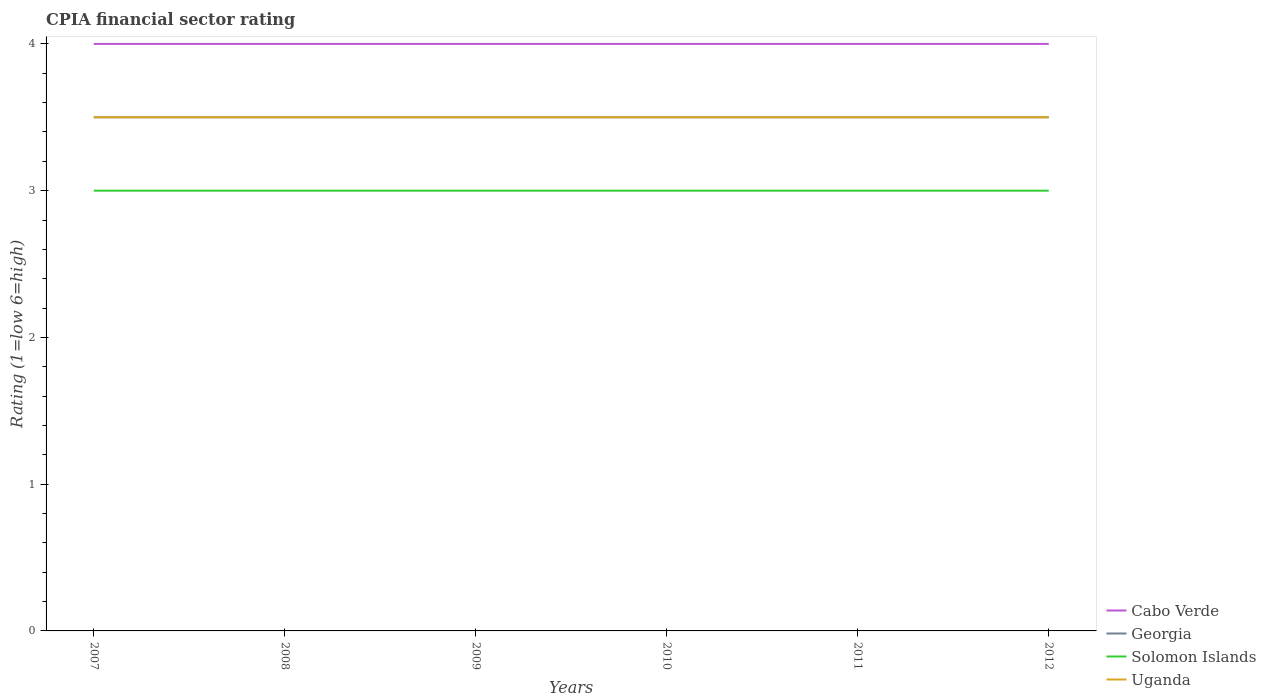How many different coloured lines are there?
Provide a succinct answer. 4. Does the line corresponding to Solomon Islands intersect with the line corresponding to Georgia?
Make the answer very short. No. What is the total CPIA rating in Solomon Islands in the graph?
Your answer should be compact. 0. Are the values on the major ticks of Y-axis written in scientific E-notation?
Your answer should be compact. No. How are the legend labels stacked?
Your response must be concise. Vertical. What is the title of the graph?
Make the answer very short. CPIA financial sector rating. Does "Guyana" appear as one of the legend labels in the graph?
Your answer should be compact. No. What is the label or title of the Y-axis?
Provide a succinct answer. Rating (1=low 6=high). What is the Rating (1=low 6=high) of Georgia in 2007?
Your response must be concise. 3.5. What is the Rating (1=low 6=high) in Solomon Islands in 2007?
Offer a very short reply. 3. What is the Rating (1=low 6=high) of Uganda in 2007?
Provide a succinct answer. 3.5. What is the Rating (1=low 6=high) in Cabo Verde in 2008?
Provide a succinct answer. 4. What is the Rating (1=low 6=high) of Georgia in 2008?
Your answer should be compact. 3.5. What is the Rating (1=low 6=high) in Uganda in 2008?
Offer a terse response. 3.5. What is the Rating (1=low 6=high) in Cabo Verde in 2009?
Offer a very short reply. 4. What is the Rating (1=low 6=high) of Georgia in 2009?
Offer a terse response. 3.5. What is the Rating (1=low 6=high) of Solomon Islands in 2009?
Offer a terse response. 3. What is the Rating (1=low 6=high) in Cabo Verde in 2010?
Give a very brief answer. 4. What is the Rating (1=low 6=high) in Georgia in 2010?
Your answer should be very brief. 3.5. What is the Rating (1=low 6=high) of Uganda in 2010?
Offer a terse response. 3.5. What is the Rating (1=low 6=high) of Solomon Islands in 2011?
Give a very brief answer. 3. What is the Rating (1=low 6=high) in Uganda in 2011?
Your response must be concise. 3.5. What is the Rating (1=low 6=high) in Cabo Verde in 2012?
Your answer should be compact. 4. What is the Rating (1=low 6=high) in Uganda in 2012?
Your response must be concise. 3.5. Across all years, what is the maximum Rating (1=low 6=high) of Georgia?
Make the answer very short. 3.5. Across all years, what is the maximum Rating (1=low 6=high) in Uganda?
Give a very brief answer. 3.5. Across all years, what is the minimum Rating (1=low 6=high) of Uganda?
Provide a short and direct response. 3.5. What is the total Rating (1=low 6=high) of Cabo Verde in the graph?
Offer a terse response. 24. What is the total Rating (1=low 6=high) in Georgia in the graph?
Your response must be concise. 21. What is the difference between the Rating (1=low 6=high) in Solomon Islands in 2007 and that in 2008?
Offer a very short reply. 0. What is the difference between the Rating (1=low 6=high) of Uganda in 2007 and that in 2008?
Ensure brevity in your answer.  0. What is the difference between the Rating (1=low 6=high) in Solomon Islands in 2007 and that in 2009?
Provide a succinct answer. 0. What is the difference between the Rating (1=low 6=high) in Uganda in 2007 and that in 2010?
Keep it short and to the point. 0. What is the difference between the Rating (1=low 6=high) in Georgia in 2007 and that in 2011?
Your answer should be compact. 0. What is the difference between the Rating (1=low 6=high) in Cabo Verde in 2007 and that in 2012?
Your answer should be very brief. 0. What is the difference between the Rating (1=low 6=high) in Georgia in 2007 and that in 2012?
Give a very brief answer. 0. What is the difference between the Rating (1=low 6=high) in Solomon Islands in 2007 and that in 2012?
Provide a succinct answer. 0. What is the difference between the Rating (1=low 6=high) of Uganda in 2008 and that in 2009?
Ensure brevity in your answer.  0. What is the difference between the Rating (1=low 6=high) of Cabo Verde in 2008 and that in 2010?
Give a very brief answer. 0. What is the difference between the Rating (1=low 6=high) of Georgia in 2008 and that in 2010?
Your answer should be very brief. 0. What is the difference between the Rating (1=low 6=high) in Solomon Islands in 2008 and that in 2010?
Provide a short and direct response. 0. What is the difference between the Rating (1=low 6=high) in Uganda in 2008 and that in 2010?
Give a very brief answer. 0. What is the difference between the Rating (1=low 6=high) in Cabo Verde in 2008 and that in 2011?
Offer a very short reply. 0. What is the difference between the Rating (1=low 6=high) in Georgia in 2008 and that in 2011?
Your answer should be very brief. 0. What is the difference between the Rating (1=low 6=high) of Solomon Islands in 2008 and that in 2011?
Your answer should be very brief. 0. What is the difference between the Rating (1=low 6=high) in Georgia in 2008 and that in 2012?
Give a very brief answer. 0. What is the difference between the Rating (1=low 6=high) in Solomon Islands in 2008 and that in 2012?
Provide a succinct answer. 0. What is the difference between the Rating (1=low 6=high) in Uganda in 2008 and that in 2012?
Your response must be concise. 0. What is the difference between the Rating (1=low 6=high) in Cabo Verde in 2009 and that in 2010?
Provide a succinct answer. 0. What is the difference between the Rating (1=low 6=high) in Solomon Islands in 2009 and that in 2010?
Your answer should be compact. 0. What is the difference between the Rating (1=low 6=high) in Uganda in 2009 and that in 2010?
Make the answer very short. 0. What is the difference between the Rating (1=low 6=high) of Cabo Verde in 2009 and that in 2011?
Your answer should be very brief. 0. What is the difference between the Rating (1=low 6=high) in Georgia in 2009 and that in 2011?
Your answer should be compact. 0. What is the difference between the Rating (1=low 6=high) of Cabo Verde in 2009 and that in 2012?
Provide a short and direct response. 0. What is the difference between the Rating (1=low 6=high) of Solomon Islands in 2009 and that in 2012?
Offer a very short reply. 0. What is the difference between the Rating (1=low 6=high) of Cabo Verde in 2010 and that in 2011?
Provide a short and direct response. 0. What is the difference between the Rating (1=low 6=high) in Cabo Verde in 2010 and that in 2012?
Your answer should be very brief. 0. What is the difference between the Rating (1=low 6=high) of Georgia in 2010 and that in 2012?
Provide a short and direct response. 0. What is the difference between the Rating (1=low 6=high) of Solomon Islands in 2010 and that in 2012?
Your response must be concise. 0. What is the difference between the Rating (1=low 6=high) in Cabo Verde in 2011 and that in 2012?
Your answer should be very brief. 0. What is the difference between the Rating (1=low 6=high) in Georgia in 2011 and that in 2012?
Provide a short and direct response. 0. What is the difference between the Rating (1=low 6=high) of Uganda in 2011 and that in 2012?
Ensure brevity in your answer.  0. What is the difference between the Rating (1=low 6=high) in Cabo Verde in 2007 and the Rating (1=low 6=high) in Uganda in 2008?
Ensure brevity in your answer.  0.5. What is the difference between the Rating (1=low 6=high) of Cabo Verde in 2007 and the Rating (1=low 6=high) of Georgia in 2009?
Provide a succinct answer. 0.5. What is the difference between the Rating (1=low 6=high) in Cabo Verde in 2007 and the Rating (1=low 6=high) in Solomon Islands in 2009?
Offer a terse response. 1. What is the difference between the Rating (1=low 6=high) of Cabo Verde in 2007 and the Rating (1=low 6=high) of Uganda in 2009?
Your answer should be very brief. 0.5. What is the difference between the Rating (1=low 6=high) in Cabo Verde in 2007 and the Rating (1=low 6=high) in Georgia in 2010?
Ensure brevity in your answer.  0.5. What is the difference between the Rating (1=low 6=high) of Cabo Verde in 2007 and the Rating (1=low 6=high) of Solomon Islands in 2010?
Make the answer very short. 1. What is the difference between the Rating (1=low 6=high) of Georgia in 2007 and the Rating (1=low 6=high) of Solomon Islands in 2010?
Your answer should be compact. 0.5. What is the difference between the Rating (1=low 6=high) in Solomon Islands in 2007 and the Rating (1=low 6=high) in Uganda in 2010?
Your answer should be very brief. -0.5. What is the difference between the Rating (1=low 6=high) of Cabo Verde in 2007 and the Rating (1=low 6=high) of Georgia in 2011?
Ensure brevity in your answer.  0.5. What is the difference between the Rating (1=low 6=high) in Cabo Verde in 2007 and the Rating (1=low 6=high) in Uganda in 2011?
Offer a very short reply. 0.5. What is the difference between the Rating (1=low 6=high) in Georgia in 2007 and the Rating (1=low 6=high) in Uganda in 2011?
Your answer should be very brief. 0. What is the difference between the Rating (1=low 6=high) in Cabo Verde in 2007 and the Rating (1=low 6=high) in Uganda in 2012?
Your answer should be very brief. 0.5. What is the difference between the Rating (1=low 6=high) in Cabo Verde in 2008 and the Rating (1=low 6=high) in Solomon Islands in 2009?
Provide a short and direct response. 1. What is the difference between the Rating (1=low 6=high) in Cabo Verde in 2008 and the Rating (1=low 6=high) in Uganda in 2009?
Keep it short and to the point. 0.5. What is the difference between the Rating (1=low 6=high) in Georgia in 2008 and the Rating (1=low 6=high) in Solomon Islands in 2009?
Your response must be concise. 0.5. What is the difference between the Rating (1=low 6=high) of Georgia in 2008 and the Rating (1=low 6=high) of Uganda in 2009?
Make the answer very short. 0. What is the difference between the Rating (1=low 6=high) of Cabo Verde in 2008 and the Rating (1=low 6=high) of Solomon Islands in 2010?
Offer a terse response. 1. What is the difference between the Rating (1=low 6=high) of Georgia in 2008 and the Rating (1=low 6=high) of Solomon Islands in 2010?
Your answer should be compact. 0.5. What is the difference between the Rating (1=low 6=high) of Georgia in 2008 and the Rating (1=low 6=high) of Uganda in 2010?
Offer a very short reply. 0. What is the difference between the Rating (1=low 6=high) of Cabo Verde in 2008 and the Rating (1=low 6=high) of Georgia in 2011?
Your answer should be compact. 0.5. What is the difference between the Rating (1=low 6=high) of Cabo Verde in 2008 and the Rating (1=low 6=high) of Solomon Islands in 2011?
Offer a very short reply. 1. What is the difference between the Rating (1=low 6=high) of Cabo Verde in 2008 and the Rating (1=low 6=high) of Uganda in 2011?
Offer a terse response. 0.5. What is the difference between the Rating (1=low 6=high) in Georgia in 2008 and the Rating (1=low 6=high) in Solomon Islands in 2011?
Make the answer very short. 0.5. What is the difference between the Rating (1=low 6=high) of Georgia in 2008 and the Rating (1=low 6=high) of Uganda in 2011?
Your answer should be very brief. 0. What is the difference between the Rating (1=low 6=high) of Cabo Verde in 2008 and the Rating (1=low 6=high) of Georgia in 2012?
Your answer should be compact. 0.5. What is the difference between the Rating (1=low 6=high) of Cabo Verde in 2008 and the Rating (1=low 6=high) of Solomon Islands in 2012?
Your answer should be compact. 1. What is the difference between the Rating (1=low 6=high) in Cabo Verde in 2008 and the Rating (1=low 6=high) in Uganda in 2012?
Make the answer very short. 0.5. What is the difference between the Rating (1=low 6=high) in Georgia in 2008 and the Rating (1=low 6=high) in Solomon Islands in 2012?
Offer a terse response. 0.5. What is the difference between the Rating (1=low 6=high) in Georgia in 2008 and the Rating (1=low 6=high) in Uganda in 2012?
Offer a terse response. 0. What is the difference between the Rating (1=low 6=high) in Cabo Verde in 2009 and the Rating (1=low 6=high) in Solomon Islands in 2010?
Provide a succinct answer. 1. What is the difference between the Rating (1=low 6=high) in Georgia in 2009 and the Rating (1=low 6=high) in Solomon Islands in 2010?
Provide a succinct answer. 0.5. What is the difference between the Rating (1=low 6=high) in Georgia in 2009 and the Rating (1=low 6=high) in Uganda in 2010?
Give a very brief answer. 0. What is the difference between the Rating (1=low 6=high) in Cabo Verde in 2009 and the Rating (1=low 6=high) in Uganda in 2011?
Your answer should be very brief. 0.5. What is the difference between the Rating (1=low 6=high) in Georgia in 2009 and the Rating (1=low 6=high) in Solomon Islands in 2011?
Provide a short and direct response. 0.5. What is the difference between the Rating (1=low 6=high) of Cabo Verde in 2009 and the Rating (1=low 6=high) of Solomon Islands in 2012?
Provide a short and direct response. 1. What is the difference between the Rating (1=low 6=high) in Cabo Verde in 2009 and the Rating (1=low 6=high) in Uganda in 2012?
Your answer should be very brief. 0.5. What is the difference between the Rating (1=low 6=high) in Georgia in 2009 and the Rating (1=low 6=high) in Solomon Islands in 2012?
Offer a very short reply. 0.5. What is the difference between the Rating (1=low 6=high) in Solomon Islands in 2009 and the Rating (1=low 6=high) in Uganda in 2012?
Provide a succinct answer. -0.5. What is the difference between the Rating (1=low 6=high) in Cabo Verde in 2010 and the Rating (1=low 6=high) in Solomon Islands in 2011?
Offer a terse response. 1. What is the difference between the Rating (1=low 6=high) in Cabo Verde in 2010 and the Rating (1=low 6=high) in Uganda in 2011?
Offer a very short reply. 0.5. What is the difference between the Rating (1=low 6=high) of Georgia in 2010 and the Rating (1=low 6=high) of Solomon Islands in 2011?
Offer a very short reply. 0.5. What is the difference between the Rating (1=low 6=high) in Georgia in 2010 and the Rating (1=low 6=high) in Uganda in 2011?
Your response must be concise. 0. What is the difference between the Rating (1=low 6=high) in Cabo Verde in 2010 and the Rating (1=low 6=high) in Georgia in 2012?
Keep it short and to the point. 0.5. What is the difference between the Rating (1=low 6=high) of Cabo Verde in 2010 and the Rating (1=low 6=high) of Solomon Islands in 2012?
Provide a short and direct response. 1. What is the difference between the Rating (1=low 6=high) in Georgia in 2010 and the Rating (1=low 6=high) in Solomon Islands in 2012?
Your answer should be very brief. 0.5. What is the difference between the Rating (1=low 6=high) of Georgia in 2010 and the Rating (1=low 6=high) of Uganda in 2012?
Provide a succinct answer. 0. What is the difference between the Rating (1=low 6=high) in Solomon Islands in 2010 and the Rating (1=low 6=high) in Uganda in 2012?
Offer a terse response. -0.5. What is the difference between the Rating (1=low 6=high) in Georgia in 2011 and the Rating (1=low 6=high) in Uganda in 2012?
Ensure brevity in your answer.  0. What is the average Rating (1=low 6=high) in Georgia per year?
Your answer should be very brief. 3.5. In the year 2007, what is the difference between the Rating (1=low 6=high) of Cabo Verde and Rating (1=low 6=high) of Solomon Islands?
Ensure brevity in your answer.  1. In the year 2007, what is the difference between the Rating (1=low 6=high) of Georgia and Rating (1=low 6=high) of Solomon Islands?
Give a very brief answer. 0.5. In the year 2007, what is the difference between the Rating (1=low 6=high) in Georgia and Rating (1=low 6=high) in Uganda?
Provide a succinct answer. 0. In the year 2008, what is the difference between the Rating (1=low 6=high) of Cabo Verde and Rating (1=low 6=high) of Georgia?
Your answer should be compact. 0.5. In the year 2008, what is the difference between the Rating (1=low 6=high) in Cabo Verde and Rating (1=low 6=high) in Solomon Islands?
Provide a short and direct response. 1. In the year 2008, what is the difference between the Rating (1=low 6=high) in Cabo Verde and Rating (1=low 6=high) in Uganda?
Keep it short and to the point. 0.5. In the year 2008, what is the difference between the Rating (1=low 6=high) of Georgia and Rating (1=low 6=high) of Solomon Islands?
Offer a terse response. 0.5. In the year 2008, what is the difference between the Rating (1=low 6=high) of Georgia and Rating (1=low 6=high) of Uganda?
Your answer should be very brief. 0. In the year 2009, what is the difference between the Rating (1=low 6=high) in Cabo Verde and Rating (1=low 6=high) in Georgia?
Offer a terse response. 0.5. In the year 2009, what is the difference between the Rating (1=low 6=high) in Cabo Verde and Rating (1=low 6=high) in Solomon Islands?
Make the answer very short. 1. In the year 2009, what is the difference between the Rating (1=low 6=high) of Cabo Verde and Rating (1=low 6=high) of Uganda?
Give a very brief answer. 0.5. In the year 2009, what is the difference between the Rating (1=low 6=high) in Solomon Islands and Rating (1=low 6=high) in Uganda?
Your answer should be compact. -0.5. In the year 2010, what is the difference between the Rating (1=low 6=high) in Georgia and Rating (1=low 6=high) in Solomon Islands?
Your answer should be very brief. 0.5. In the year 2011, what is the difference between the Rating (1=low 6=high) of Cabo Verde and Rating (1=low 6=high) of Georgia?
Offer a terse response. 0.5. In the year 2011, what is the difference between the Rating (1=low 6=high) of Cabo Verde and Rating (1=low 6=high) of Solomon Islands?
Provide a short and direct response. 1. In the year 2011, what is the difference between the Rating (1=low 6=high) in Cabo Verde and Rating (1=low 6=high) in Uganda?
Offer a very short reply. 0.5. In the year 2011, what is the difference between the Rating (1=low 6=high) in Georgia and Rating (1=low 6=high) in Uganda?
Give a very brief answer. 0. In the year 2011, what is the difference between the Rating (1=low 6=high) of Solomon Islands and Rating (1=low 6=high) of Uganda?
Your response must be concise. -0.5. In the year 2012, what is the difference between the Rating (1=low 6=high) in Cabo Verde and Rating (1=low 6=high) in Solomon Islands?
Offer a terse response. 1. In the year 2012, what is the difference between the Rating (1=low 6=high) of Georgia and Rating (1=low 6=high) of Solomon Islands?
Keep it short and to the point. 0.5. In the year 2012, what is the difference between the Rating (1=low 6=high) in Solomon Islands and Rating (1=low 6=high) in Uganda?
Provide a short and direct response. -0.5. What is the ratio of the Rating (1=low 6=high) of Cabo Verde in 2007 to that in 2008?
Offer a terse response. 1. What is the ratio of the Rating (1=low 6=high) in Georgia in 2007 to that in 2008?
Make the answer very short. 1. What is the ratio of the Rating (1=low 6=high) in Georgia in 2007 to that in 2009?
Keep it short and to the point. 1. What is the ratio of the Rating (1=low 6=high) in Solomon Islands in 2007 to that in 2009?
Offer a very short reply. 1. What is the ratio of the Rating (1=low 6=high) in Uganda in 2007 to that in 2009?
Your answer should be very brief. 1. What is the ratio of the Rating (1=low 6=high) in Georgia in 2007 to that in 2011?
Give a very brief answer. 1. What is the ratio of the Rating (1=low 6=high) of Solomon Islands in 2007 to that in 2011?
Offer a terse response. 1. What is the ratio of the Rating (1=low 6=high) of Cabo Verde in 2007 to that in 2012?
Provide a short and direct response. 1. What is the ratio of the Rating (1=low 6=high) of Solomon Islands in 2007 to that in 2012?
Offer a terse response. 1. What is the ratio of the Rating (1=low 6=high) in Georgia in 2008 to that in 2009?
Your answer should be compact. 1. What is the ratio of the Rating (1=low 6=high) of Solomon Islands in 2008 to that in 2009?
Make the answer very short. 1. What is the ratio of the Rating (1=low 6=high) in Uganda in 2008 to that in 2009?
Provide a short and direct response. 1. What is the ratio of the Rating (1=low 6=high) in Georgia in 2008 to that in 2010?
Your response must be concise. 1. What is the ratio of the Rating (1=low 6=high) in Solomon Islands in 2008 to that in 2011?
Offer a very short reply. 1. What is the ratio of the Rating (1=low 6=high) in Uganda in 2008 to that in 2012?
Keep it short and to the point. 1. What is the ratio of the Rating (1=low 6=high) of Cabo Verde in 2009 to that in 2010?
Ensure brevity in your answer.  1. What is the ratio of the Rating (1=low 6=high) in Georgia in 2009 to that in 2010?
Your answer should be very brief. 1. What is the ratio of the Rating (1=low 6=high) of Uganda in 2009 to that in 2010?
Offer a terse response. 1. What is the ratio of the Rating (1=low 6=high) in Solomon Islands in 2009 to that in 2011?
Provide a short and direct response. 1. What is the ratio of the Rating (1=low 6=high) in Uganda in 2009 to that in 2011?
Provide a short and direct response. 1. What is the ratio of the Rating (1=low 6=high) of Georgia in 2009 to that in 2012?
Offer a terse response. 1. What is the ratio of the Rating (1=low 6=high) of Solomon Islands in 2009 to that in 2012?
Offer a terse response. 1. What is the ratio of the Rating (1=low 6=high) in Uganda in 2009 to that in 2012?
Your response must be concise. 1. What is the ratio of the Rating (1=low 6=high) in Cabo Verde in 2010 to that in 2011?
Your answer should be very brief. 1. What is the ratio of the Rating (1=low 6=high) of Solomon Islands in 2010 to that in 2011?
Provide a short and direct response. 1. What is the ratio of the Rating (1=low 6=high) of Uganda in 2010 to that in 2011?
Provide a succinct answer. 1. What is the ratio of the Rating (1=low 6=high) in Cabo Verde in 2010 to that in 2012?
Offer a very short reply. 1. What is the ratio of the Rating (1=low 6=high) of Georgia in 2010 to that in 2012?
Your response must be concise. 1. What is the ratio of the Rating (1=low 6=high) of Georgia in 2011 to that in 2012?
Your response must be concise. 1. What is the difference between the highest and the lowest Rating (1=low 6=high) of Cabo Verde?
Provide a succinct answer. 0. What is the difference between the highest and the lowest Rating (1=low 6=high) in Uganda?
Give a very brief answer. 0. 